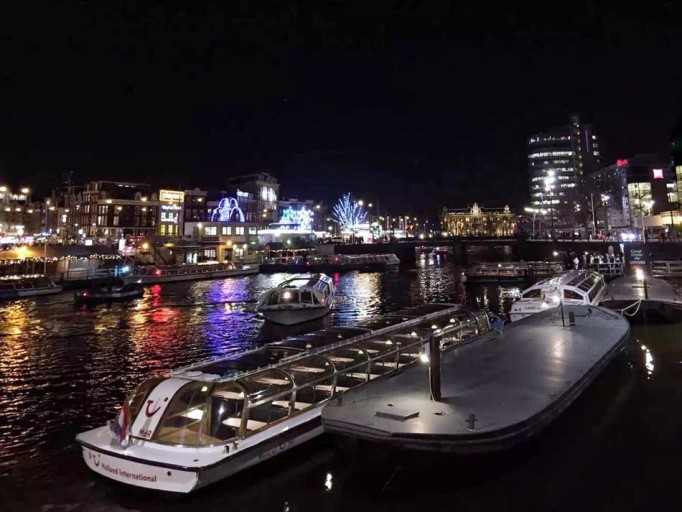How many boats would there be in the image if someone added two more boats in the picture? If two more boats were added to the image, there would be a total of 5 boats visible, lending even more charm to the vibrant night scene by the water. 